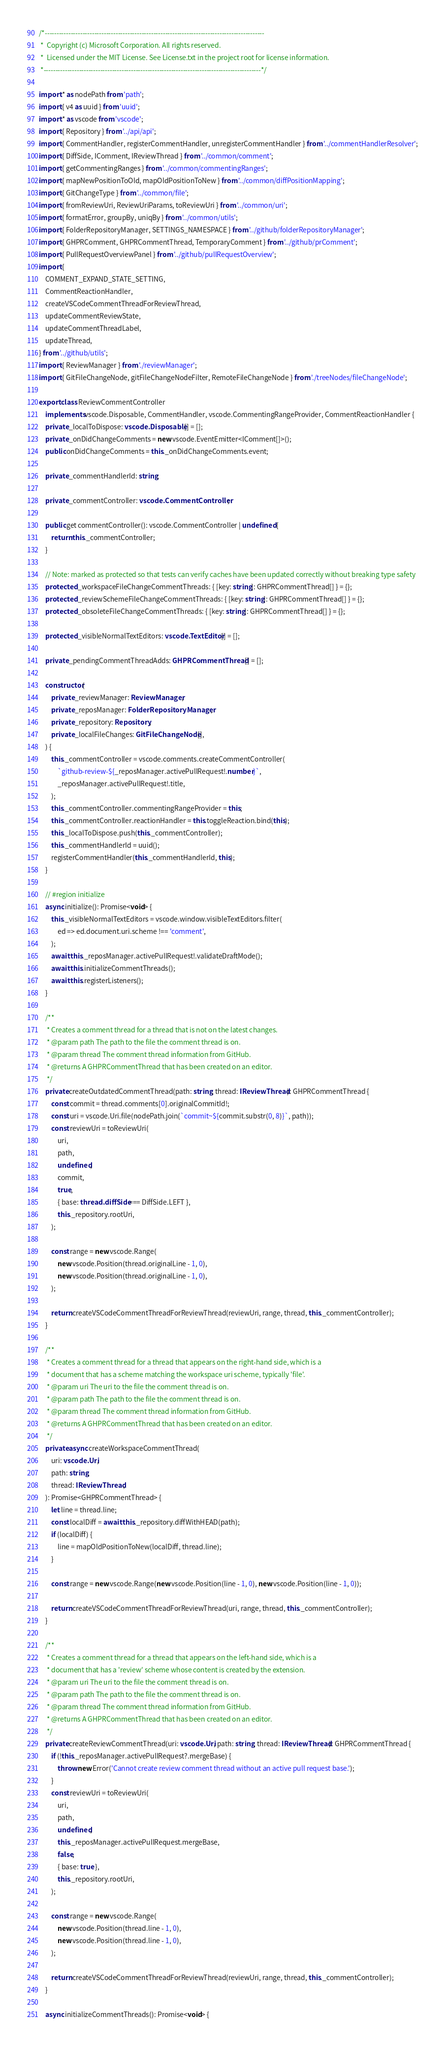<code> <loc_0><loc_0><loc_500><loc_500><_TypeScript_>/*---------------------------------------------------------------------------------------------
 *  Copyright (c) Microsoft Corporation. All rights reserved.
 *  Licensed under the MIT License. See License.txt in the project root for license information.
 *--------------------------------------------------------------------------------------------*/

import * as nodePath from 'path';
import { v4 as uuid } from 'uuid';
import * as vscode from 'vscode';
import { Repository } from '../api/api';
import { CommentHandler, registerCommentHandler, unregisterCommentHandler } from '../commentHandlerResolver';
import { DiffSide, IComment, IReviewThread } from '../common/comment';
import { getCommentingRanges } from '../common/commentingRanges';
import { mapNewPositionToOld, mapOldPositionToNew } from '../common/diffPositionMapping';
import { GitChangeType } from '../common/file';
import { fromReviewUri, ReviewUriParams, toReviewUri } from '../common/uri';
import { formatError, groupBy, uniqBy } from '../common/utils';
import { FolderRepositoryManager, SETTINGS_NAMESPACE } from '../github/folderRepositoryManager';
import { GHPRComment, GHPRCommentThread, TemporaryComment } from '../github/prComment';
import { PullRequestOverviewPanel } from '../github/pullRequestOverview';
import {
	COMMENT_EXPAND_STATE_SETTING,
	CommentReactionHandler,
	createVSCodeCommentThreadForReviewThread,
	updateCommentReviewState,
	updateCommentThreadLabel,
	updateThread,
} from '../github/utils';
import { ReviewManager } from './reviewManager';
import { GitFileChangeNode, gitFileChangeNodeFilter, RemoteFileChangeNode } from './treeNodes/fileChangeNode';

export class ReviewCommentController
	implements vscode.Disposable, CommentHandler, vscode.CommentingRangeProvider, CommentReactionHandler {
	private _localToDispose: vscode.Disposable[] = [];
	private _onDidChangeComments = new vscode.EventEmitter<IComment[]>();
	public onDidChangeComments = this._onDidChangeComments.event;

	private _commentHandlerId: string;

	private _commentController: vscode.CommentController;

	public get commentController(): vscode.CommentController | undefined {
		return this._commentController;
	}

	// Note: marked as protected so that tests can verify caches have been updated correctly without breaking type safety
	protected _workspaceFileChangeCommentThreads: { [key: string]: GHPRCommentThread[] } = {};
	protected _reviewSchemeFileChangeCommentThreads: { [key: string]: GHPRCommentThread[] } = {};
	protected _obsoleteFileChangeCommentThreads: { [key: string]: GHPRCommentThread[] } = {};

	protected _visibleNormalTextEditors: vscode.TextEditor[] = [];

	private _pendingCommentThreadAdds: GHPRCommentThread[] = [];

	constructor(
		private _reviewManager: ReviewManager,
		private _reposManager: FolderRepositoryManager,
		private _repository: Repository,
		private _localFileChanges: GitFileChangeNode[],
	) {
		this._commentController = vscode.comments.createCommentController(
			`github-review-${_reposManager.activePullRequest!.number}`,
			_reposManager.activePullRequest!.title,
		);
		this._commentController.commentingRangeProvider = this;
		this._commentController.reactionHandler = this.toggleReaction.bind(this);
		this._localToDispose.push(this._commentController);
		this._commentHandlerId = uuid();
		registerCommentHandler(this._commentHandlerId, this);
	}

	// #region initialize
	async initialize(): Promise<void> {
		this._visibleNormalTextEditors = vscode.window.visibleTextEditors.filter(
			ed => ed.document.uri.scheme !== 'comment',
		);
		await this._reposManager.activePullRequest!.validateDraftMode();
		await this.initializeCommentThreads();
		await this.registerListeners();
	}

	/**
	 * Creates a comment thread for a thread that is not on the latest changes.
	 * @param path The path to the file the comment thread is on.
	 * @param thread The comment thread information from GitHub.
	 * @returns A GHPRCommentThread that has been created on an editor.
	 */
	private createOutdatedCommentThread(path: string, thread: IReviewThread): GHPRCommentThread {
		const commit = thread.comments[0].originalCommitId!;
		const uri = vscode.Uri.file(nodePath.join(`commit~${commit.substr(0, 8)}`, path));
		const reviewUri = toReviewUri(
			uri,
			path,
			undefined,
			commit,
			true,
			{ base: thread.diffSide === DiffSide.LEFT },
			this._repository.rootUri,
		);

		const range = new vscode.Range(
			new vscode.Position(thread.originalLine - 1, 0),
			new vscode.Position(thread.originalLine - 1, 0),
		);

		return createVSCodeCommentThreadForReviewThread(reviewUri, range, thread, this._commentController);
	}

	/**
	 * Creates a comment thread for a thread that appears on the right-hand side, which is a
	 * document that has a scheme matching the workspace uri scheme, typically 'file'.
	 * @param uri The uri to the file the comment thread is on.
	 * @param path The path to the file the comment thread is on.
	 * @param thread The comment thread information from GitHub.
	 * @returns A GHPRCommentThread that has been created on an editor.
	 */
	private async createWorkspaceCommentThread(
		uri: vscode.Uri,
		path: string,
		thread: IReviewThread,
	): Promise<GHPRCommentThread> {
		let line = thread.line;
		const localDiff = await this._repository.diffWithHEAD(path);
		if (localDiff) {
			line = mapOldPositionToNew(localDiff, thread.line);
		}

		const range = new vscode.Range(new vscode.Position(line - 1, 0), new vscode.Position(line - 1, 0));

		return createVSCodeCommentThreadForReviewThread(uri, range, thread, this._commentController);
	}

	/**
	 * Creates a comment thread for a thread that appears on the left-hand side, which is a
	 * document that has a 'review' scheme whose content is created by the extension.
	 * @param uri The uri to the file the comment thread is on.
	 * @param path The path to the file the comment thread is on.
	 * @param thread The comment thread information from GitHub.
	 * @returns A GHPRCommentThread that has been created on an editor.
	 */
	private createReviewCommentThread(uri: vscode.Uri, path: string, thread: IReviewThread): GHPRCommentThread {
		if (!this._reposManager.activePullRequest?.mergeBase) {
			throw new Error('Cannot create review comment thread without an active pull request base.');
		}
		const reviewUri = toReviewUri(
			uri,
			path,
			undefined,
			this._reposManager.activePullRequest.mergeBase,
			false,
			{ base: true },
			this._repository.rootUri,
		);

		const range = new vscode.Range(
			new vscode.Position(thread.line - 1, 0),
			new vscode.Position(thread.line - 1, 0),
		);

		return createVSCodeCommentThreadForReviewThread(reviewUri, range, thread, this._commentController);
	}

	async initializeCommentThreads(): Promise<void> {</code> 